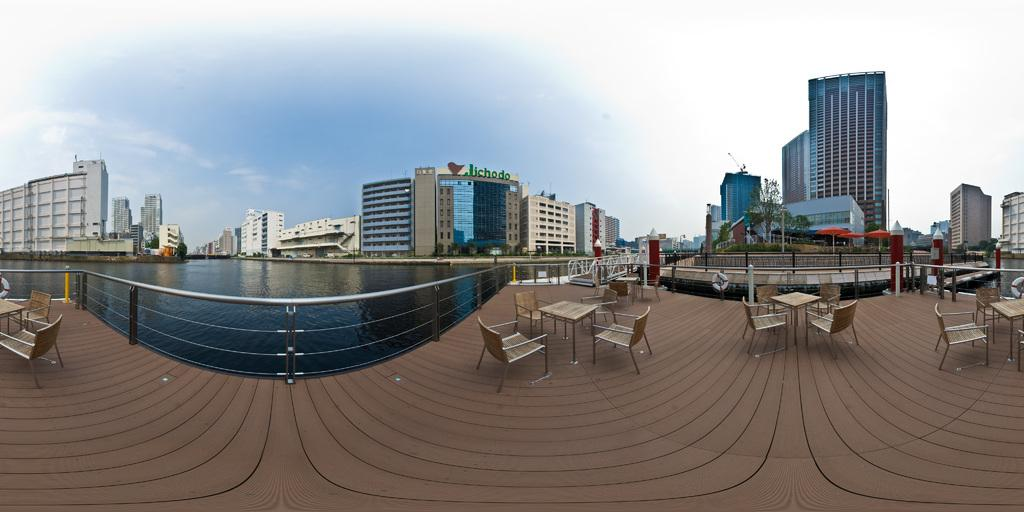What type of furniture can be seen in the image? There are chairs and tables in the image. What type of structure is present in the image? There is a fence in the image. What natural element is visible in the image? There is water visible in the image. What type of man-made structures can be seen in the image? There are buildings in the image. What type of vegetation is present in the image? There are trees in the image. What type of object is present for providing shade? There are umbrellas in the image. What is visible in the background of the image? The sky is visible in the background of the image. Where is the basin located in the image? There is no basin present in the image. What type of discussion is taking place in the image? There is no discussion taking place in the image; it is a still image. What color is the eye of the person in the image? There is no person present in the image, so there is no eye to describe. 